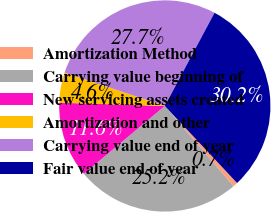Convert chart to OTSL. <chart><loc_0><loc_0><loc_500><loc_500><pie_chart><fcel>Amortization Method<fcel>Carrying value beginning of<fcel>New servicing assets created<fcel>Amortization and other<fcel>Carrying value end of year<fcel>Fair value end of year<nl><fcel>0.72%<fcel>25.17%<fcel>11.6%<fcel>4.62%<fcel>27.69%<fcel>30.21%<nl></chart> 